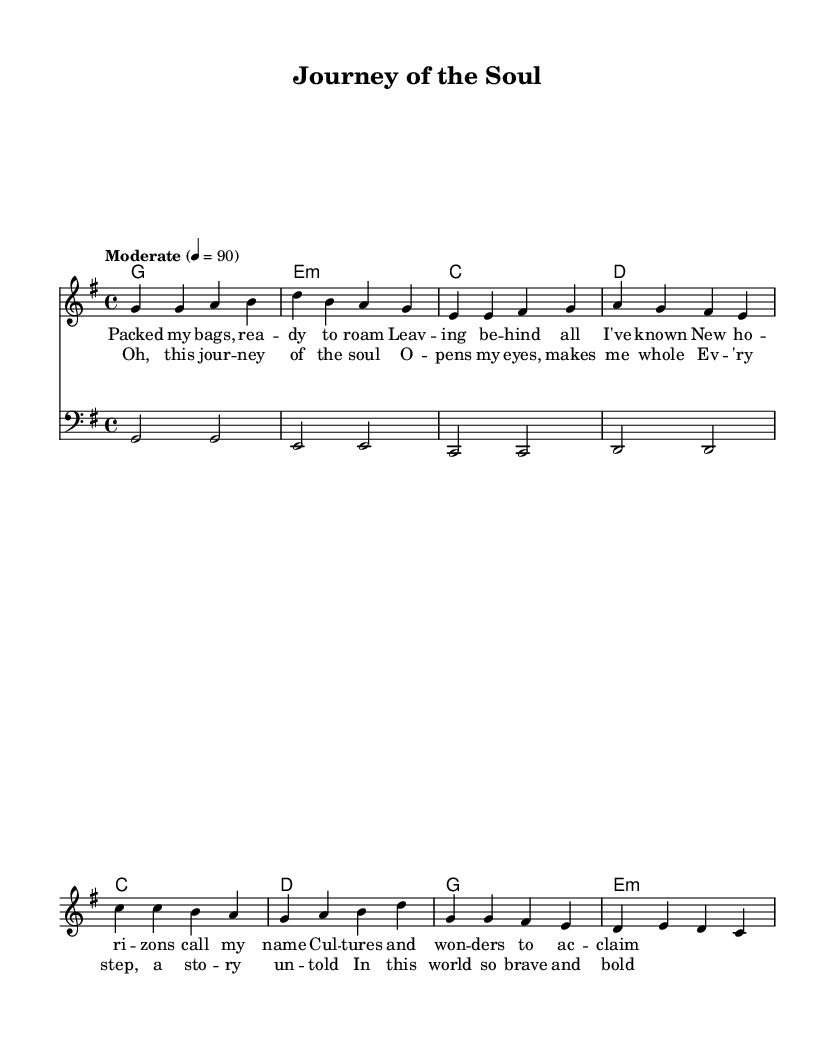What is the key signature of this music? The key signature is G major, which has one sharp. It can be identified by looking at the beginning of the staff where the sharps are placed.
Answer: G major What is the time signature of this music? The time signature is 4/4, indicated at the beginning of the score. This means there are four beats in each measure, and the quarter note receives one beat.
Answer: 4/4 What is the tempo marking of this piece? The tempo marking indicates that the piece should be played at a moderate pace of 90 beats per minute. This is specified alongside the tempo indication at the start of the score.
Answer: Moderate 4 = 90 How many measures are there in the verse section? By counting the vertical lines between the notes in the verse section, I see that there are four measures. This is part of the structural layout of the music.
Answer: 4 What emotions or themes are conveyed in the lyrics of the chorus? The chorus lyrics reflect feelings of exploration and personal growth, suggesting themes of discovery and the impact of travel on one's soul. This can be discerned by analyzing the words used in the lyrics.
Answer: Exploration and growth Which musical element is primarily characterized by the bass part in this piece? The bass part primarily provides harmonic foundation and rhythm, supporting the melody above while also adding depth to the overall arrangement. This can be observed by how the bass notes relate to the chords and melody.
Answer: Harmonic foundation 